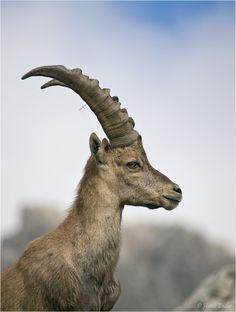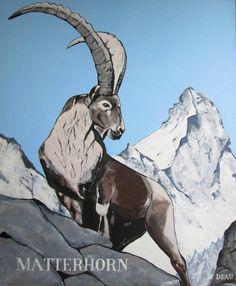The first image is the image on the left, the second image is the image on the right. For the images shown, is this caption "The ram/goat on the left is overlooking a jump." true? Answer yes or no. No. The first image is the image on the left, the second image is the image on the right. For the images displayed, is the sentence "The right image contains a horned animal looking at the camera." factually correct? Answer yes or no. No. 